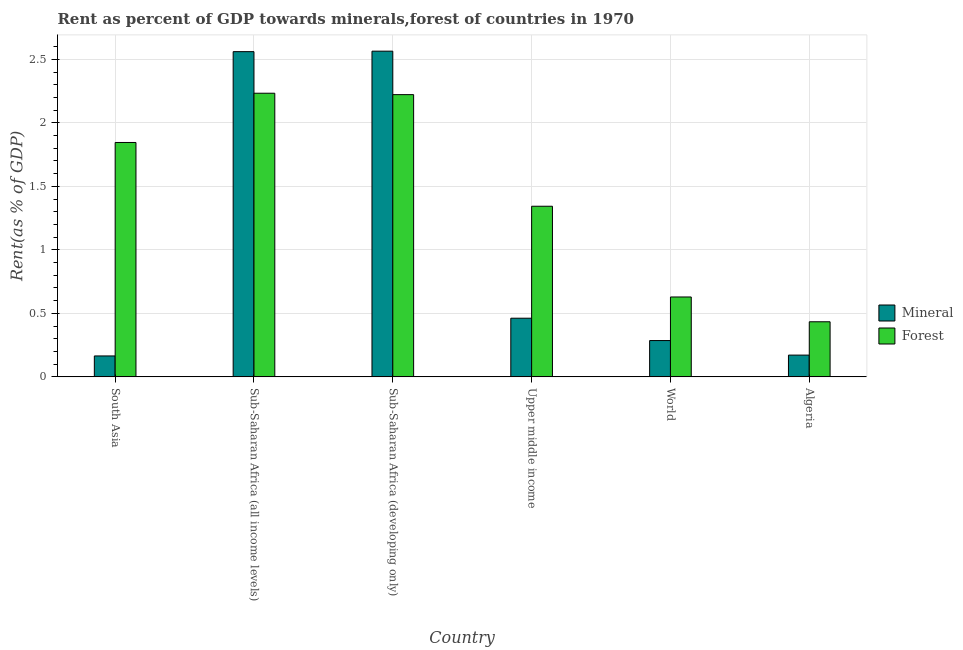Are the number of bars on each tick of the X-axis equal?
Offer a terse response. Yes. How many bars are there on the 4th tick from the left?
Provide a succinct answer. 2. What is the label of the 6th group of bars from the left?
Provide a short and direct response. Algeria. In how many cases, is the number of bars for a given country not equal to the number of legend labels?
Your answer should be very brief. 0. What is the forest rent in Upper middle income?
Keep it short and to the point. 1.34. Across all countries, what is the maximum mineral rent?
Provide a succinct answer. 2.56. Across all countries, what is the minimum mineral rent?
Keep it short and to the point. 0.16. In which country was the forest rent maximum?
Provide a short and direct response. Sub-Saharan Africa (all income levels). In which country was the forest rent minimum?
Your answer should be compact. Algeria. What is the total forest rent in the graph?
Keep it short and to the point. 8.71. What is the difference between the mineral rent in Sub-Saharan Africa (all income levels) and that in Upper middle income?
Make the answer very short. 2.1. What is the difference between the mineral rent in Sub-Saharan Africa (developing only) and the forest rent in South Asia?
Your answer should be very brief. 0.72. What is the average forest rent per country?
Offer a very short reply. 1.45. What is the difference between the mineral rent and forest rent in Sub-Saharan Africa (all income levels)?
Your answer should be compact. 0.33. What is the ratio of the mineral rent in Upper middle income to that in World?
Your response must be concise. 1.62. Is the difference between the forest rent in Algeria and World greater than the difference between the mineral rent in Algeria and World?
Keep it short and to the point. No. What is the difference between the highest and the second highest forest rent?
Make the answer very short. 0.01. What is the difference between the highest and the lowest mineral rent?
Your answer should be compact. 2.4. What does the 2nd bar from the left in Algeria represents?
Offer a terse response. Forest. What does the 2nd bar from the right in Upper middle income represents?
Offer a very short reply. Mineral. How many bars are there?
Make the answer very short. 12. How many countries are there in the graph?
Your answer should be compact. 6. Are the values on the major ticks of Y-axis written in scientific E-notation?
Ensure brevity in your answer.  No. Does the graph contain any zero values?
Offer a very short reply. No. Does the graph contain grids?
Your answer should be compact. Yes. Where does the legend appear in the graph?
Ensure brevity in your answer.  Center right. What is the title of the graph?
Ensure brevity in your answer.  Rent as percent of GDP towards minerals,forest of countries in 1970. What is the label or title of the X-axis?
Your response must be concise. Country. What is the label or title of the Y-axis?
Your answer should be very brief. Rent(as % of GDP). What is the Rent(as % of GDP) of Mineral in South Asia?
Keep it short and to the point. 0.16. What is the Rent(as % of GDP) of Forest in South Asia?
Give a very brief answer. 1.85. What is the Rent(as % of GDP) of Mineral in Sub-Saharan Africa (all income levels)?
Give a very brief answer. 2.56. What is the Rent(as % of GDP) in Forest in Sub-Saharan Africa (all income levels)?
Your answer should be compact. 2.23. What is the Rent(as % of GDP) of Mineral in Sub-Saharan Africa (developing only)?
Your answer should be very brief. 2.56. What is the Rent(as % of GDP) in Forest in Sub-Saharan Africa (developing only)?
Provide a succinct answer. 2.22. What is the Rent(as % of GDP) in Mineral in Upper middle income?
Your response must be concise. 0.46. What is the Rent(as % of GDP) in Forest in Upper middle income?
Offer a very short reply. 1.34. What is the Rent(as % of GDP) of Mineral in World?
Your answer should be very brief. 0.29. What is the Rent(as % of GDP) of Forest in World?
Your response must be concise. 0.63. What is the Rent(as % of GDP) in Mineral in Algeria?
Offer a very short reply. 0.17. What is the Rent(as % of GDP) of Forest in Algeria?
Provide a succinct answer. 0.43. Across all countries, what is the maximum Rent(as % of GDP) of Mineral?
Offer a very short reply. 2.56. Across all countries, what is the maximum Rent(as % of GDP) of Forest?
Give a very brief answer. 2.23. Across all countries, what is the minimum Rent(as % of GDP) of Mineral?
Your response must be concise. 0.16. Across all countries, what is the minimum Rent(as % of GDP) of Forest?
Offer a terse response. 0.43. What is the total Rent(as % of GDP) in Mineral in the graph?
Give a very brief answer. 6.21. What is the total Rent(as % of GDP) of Forest in the graph?
Make the answer very short. 8.71. What is the difference between the Rent(as % of GDP) of Mineral in South Asia and that in Sub-Saharan Africa (all income levels)?
Keep it short and to the point. -2.4. What is the difference between the Rent(as % of GDP) of Forest in South Asia and that in Sub-Saharan Africa (all income levels)?
Provide a succinct answer. -0.39. What is the difference between the Rent(as % of GDP) of Mineral in South Asia and that in Sub-Saharan Africa (developing only)?
Give a very brief answer. -2.4. What is the difference between the Rent(as % of GDP) in Forest in South Asia and that in Sub-Saharan Africa (developing only)?
Provide a succinct answer. -0.38. What is the difference between the Rent(as % of GDP) in Mineral in South Asia and that in Upper middle income?
Provide a short and direct response. -0.3. What is the difference between the Rent(as % of GDP) in Forest in South Asia and that in Upper middle income?
Offer a terse response. 0.5. What is the difference between the Rent(as % of GDP) in Mineral in South Asia and that in World?
Provide a short and direct response. -0.12. What is the difference between the Rent(as % of GDP) in Forest in South Asia and that in World?
Give a very brief answer. 1.22. What is the difference between the Rent(as % of GDP) of Mineral in South Asia and that in Algeria?
Ensure brevity in your answer.  -0.01. What is the difference between the Rent(as % of GDP) of Forest in South Asia and that in Algeria?
Provide a succinct answer. 1.41. What is the difference between the Rent(as % of GDP) in Mineral in Sub-Saharan Africa (all income levels) and that in Sub-Saharan Africa (developing only)?
Provide a short and direct response. -0. What is the difference between the Rent(as % of GDP) in Forest in Sub-Saharan Africa (all income levels) and that in Sub-Saharan Africa (developing only)?
Make the answer very short. 0.01. What is the difference between the Rent(as % of GDP) in Mineral in Sub-Saharan Africa (all income levels) and that in Upper middle income?
Give a very brief answer. 2.1. What is the difference between the Rent(as % of GDP) in Forest in Sub-Saharan Africa (all income levels) and that in Upper middle income?
Your response must be concise. 0.89. What is the difference between the Rent(as % of GDP) of Mineral in Sub-Saharan Africa (all income levels) and that in World?
Provide a succinct answer. 2.27. What is the difference between the Rent(as % of GDP) of Forest in Sub-Saharan Africa (all income levels) and that in World?
Offer a terse response. 1.6. What is the difference between the Rent(as % of GDP) of Mineral in Sub-Saharan Africa (all income levels) and that in Algeria?
Provide a short and direct response. 2.39. What is the difference between the Rent(as % of GDP) in Forest in Sub-Saharan Africa (all income levels) and that in Algeria?
Provide a short and direct response. 1.8. What is the difference between the Rent(as % of GDP) of Mineral in Sub-Saharan Africa (developing only) and that in Upper middle income?
Your answer should be very brief. 2.1. What is the difference between the Rent(as % of GDP) in Forest in Sub-Saharan Africa (developing only) and that in Upper middle income?
Keep it short and to the point. 0.88. What is the difference between the Rent(as % of GDP) of Mineral in Sub-Saharan Africa (developing only) and that in World?
Keep it short and to the point. 2.28. What is the difference between the Rent(as % of GDP) in Forest in Sub-Saharan Africa (developing only) and that in World?
Provide a short and direct response. 1.59. What is the difference between the Rent(as % of GDP) of Mineral in Sub-Saharan Africa (developing only) and that in Algeria?
Offer a terse response. 2.39. What is the difference between the Rent(as % of GDP) of Forest in Sub-Saharan Africa (developing only) and that in Algeria?
Your response must be concise. 1.79. What is the difference between the Rent(as % of GDP) in Mineral in Upper middle income and that in World?
Offer a very short reply. 0.18. What is the difference between the Rent(as % of GDP) in Forest in Upper middle income and that in World?
Provide a short and direct response. 0.71. What is the difference between the Rent(as % of GDP) in Mineral in Upper middle income and that in Algeria?
Give a very brief answer. 0.29. What is the difference between the Rent(as % of GDP) of Forest in Upper middle income and that in Algeria?
Provide a short and direct response. 0.91. What is the difference between the Rent(as % of GDP) in Mineral in World and that in Algeria?
Your response must be concise. 0.11. What is the difference between the Rent(as % of GDP) in Forest in World and that in Algeria?
Give a very brief answer. 0.2. What is the difference between the Rent(as % of GDP) of Mineral in South Asia and the Rent(as % of GDP) of Forest in Sub-Saharan Africa (all income levels)?
Your answer should be very brief. -2.07. What is the difference between the Rent(as % of GDP) in Mineral in South Asia and the Rent(as % of GDP) in Forest in Sub-Saharan Africa (developing only)?
Offer a terse response. -2.06. What is the difference between the Rent(as % of GDP) of Mineral in South Asia and the Rent(as % of GDP) of Forest in Upper middle income?
Provide a short and direct response. -1.18. What is the difference between the Rent(as % of GDP) of Mineral in South Asia and the Rent(as % of GDP) of Forest in World?
Give a very brief answer. -0.46. What is the difference between the Rent(as % of GDP) of Mineral in South Asia and the Rent(as % of GDP) of Forest in Algeria?
Provide a succinct answer. -0.27. What is the difference between the Rent(as % of GDP) of Mineral in Sub-Saharan Africa (all income levels) and the Rent(as % of GDP) of Forest in Sub-Saharan Africa (developing only)?
Your response must be concise. 0.34. What is the difference between the Rent(as % of GDP) in Mineral in Sub-Saharan Africa (all income levels) and the Rent(as % of GDP) in Forest in Upper middle income?
Offer a very short reply. 1.22. What is the difference between the Rent(as % of GDP) in Mineral in Sub-Saharan Africa (all income levels) and the Rent(as % of GDP) in Forest in World?
Provide a succinct answer. 1.93. What is the difference between the Rent(as % of GDP) of Mineral in Sub-Saharan Africa (all income levels) and the Rent(as % of GDP) of Forest in Algeria?
Provide a succinct answer. 2.13. What is the difference between the Rent(as % of GDP) in Mineral in Sub-Saharan Africa (developing only) and the Rent(as % of GDP) in Forest in Upper middle income?
Give a very brief answer. 1.22. What is the difference between the Rent(as % of GDP) in Mineral in Sub-Saharan Africa (developing only) and the Rent(as % of GDP) in Forest in World?
Offer a very short reply. 1.94. What is the difference between the Rent(as % of GDP) of Mineral in Sub-Saharan Africa (developing only) and the Rent(as % of GDP) of Forest in Algeria?
Your answer should be very brief. 2.13. What is the difference between the Rent(as % of GDP) in Mineral in Upper middle income and the Rent(as % of GDP) in Forest in World?
Offer a very short reply. -0.17. What is the difference between the Rent(as % of GDP) in Mineral in Upper middle income and the Rent(as % of GDP) in Forest in Algeria?
Offer a very short reply. 0.03. What is the difference between the Rent(as % of GDP) of Mineral in World and the Rent(as % of GDP) of Forest in Algeria?
Ensure brevity in your answer.  -0.15. What is the average Rent(as % of GDP) of Mineral per country?
Offer a terse response. 1.03. What is the average Rent(as % of GDP) in Forest per country?
Keep it short and to the point. 1.45. What is the difference between the Rent(as % of GDP) of Mineral and Rent(as % of GDP) of Forest in South Asia?
Give a very brief answer. -1.68. What is the difference between the Rent(as % of GDP) of Mineral and Rent(as % of GDP) of Forest in Sub-Saharan Africa (all income levels)?
Your answer should be compact. 0.33. What is the difference between the Rent(as % of GDP) of Mineral and Rent(as % of GDP) of Forest in Sub-Saharan Africa (developing only)?
Provide a short and direct response. 0.34. What is the difference between the Rent(as % of GDP) of Mineral and Rent(as % of GDP) of Forest in Upper middle income?
Provide a succinct answer. -0.88. What is the difference between the Rent(as % of GDP) in Mineral and Rent(as % of GDP) in Forest in World?
Make the answer very short. -0.34. What is the difference between the Rent(as % of GDP) in Mineral and Rent(as % of GDP) in Forest in Algeria?
Your answer should be compact. -0.26. What is the ratio of the Rent(as % of GDP) in Mineral in South Asia to that in Sub-Saharan Africa (all income levels)?
Provide a short and direct response. 0.06. What is the ratio of the Rent(as % of GDP) of Forest in South Asia to that in Sub-Saharan Africa (all income levels)?
Give a very brief answer. 0.83. What is the ratio of the Rent(as % of GDP) in Mineral in South Asia to that in Sub-Saharan Africa (developing only)?
Your answer should be compact. 0.06. What is the ratio of the Rent(as % of GDP) of Forest in South Asia to that in Sub-Saharan Africa (developing only)?
Provide a short and direct response. 0.83. What is the ratio of the Rent(as % of GDP) in Mineral in South Asia to that in Upper middle income?
Make the answer very short. 0.36. What is the ratio of the Rent(as % of GDP) in Forest in South Asia to that in Upper middle income?
Make the answer very short. 1.37. What is the ratio of the Rent(as % of GDP) in Mineral in South Asia to that in World?
Provide a succinct answer. 0.58. What is the ratio of the Rent(as % of GDP) in Forest in South Asia to that in World?
Ensure brevity in your answer.  2.93. What is the ratio of the Rent(as % of GDP) in Mineral in South Asia to that in Algeria?
Your answer should be compact. 0.96. What is the ratio of the Rent(as % of GDP) of Forest in South Asia to that in Algeria?
Provide a succinct answer. 4.25. What is the ratio of the Rent(as % of GDP) in Forest in Sub-Saharan Africa (all income levels) to that in Sub-Saharan Africa (developing only)?
Make the answer very short. 1. What is the ratio of the Rent(as % of GDP) in Mineral in Sub-Saharan Africa (all income levels) to that in Upper middle income?
Ensure brevity in your answer.  5.54. What is the ratio of the Rent(as % of GDP) in Forest in Sub-Saharan Africa (all income levels) to that in Upper middle income?
Make the answer very short. 1.66. What is the ratio of the Rent(as % of GDP) of Mineral in Sub-Saharan Africa (all income levels) to that in World?
Provide a short and direct response. 8.95. What is the ratio of the Rent(as % of GDP) in Forest in Sub-Saharan Africa (all income levels) to that in World?
Your answer should be very brief. 3.55. What is the ratio of the Rent(as % of GDP) of Mineral in Sub-Saharan Africa (all income levels) to that in Algeria?
Give a very brief answer. 14.94. What is the ratio of the Rent(as % of GDP) of Forest in Sub-Saharan Africa (all income levels) to that in Algeria?
Provide a succinct answer. 5.15. What is the ratio of the Rent(as % of GDP) of Mineral in Sub-Saharan Africa (developing only) to that in Upper middle income?
Make the answer very short. 5.55. What is the ratio of the Rent(as % of GDP) of Forest in Sub-Saharan Africa (developing only) to that in Upper middle income?
Offer a terse response. 1.65. What is the ratio of the Rent(as % of GDP) of Mineral in Sub-Saharan Africa (developing only) to that in World?
Offer a very short reply. 8.97. What is the ratio of the Rent(as % of GDP) in Forest in Sub-Saharan Africa (developing only) to that in World?
Give a very brief answer. 3.53. What is the ratio of the Rent(as % of GDP) in Mineral in Sub-Saharan Africa (developing only) to that in Algeria?
Give a very brief answer. 14.96. What is the ratio of the Rent(as % of GDP) of Forest in Sub-Saharan Africa (developing only) to that in Algeria?
Offer a very short reply. 5.12. What is the ratio of the Rent(as % of GDP) of Mineral in Upper middle income to that in World?
Your answer should be very brief. 1.62. What is the ratio of the Rent(as % of GDP) in Forest in Upper middle income to that in World?
Provide a succinct answer. 2.14. What is the ratio of the Rent(as % of GDP) of Mineral in Upper middle income to that in Algeria?
Your response must be concise. 2.69. What is the ratio of the Rent(as % of GDP) of Forest in Upper middle income to that in Algeria?
Offer a terse response. 3.1. What is the ratio of the Rent(as % of GDP) in Mineral in World to that in Algeria?
Offer a terse response. 1.67. What is the ratio of the Rent(as % of GDP) in Forest in World to that in Algeria?
Keep it short and to the point. 1.45. What is the difference between the highest and the second highest Rent(as % of GDP) in Mineral?
Keep it short and to the point. 0. What is the difference between the highest and the second highest Rent(as % of GDP) in Forest?
Provide a short and direct response. 0.01. What is the difference between the highest and the lowest Rent(as % of GDP) of Mineral?
Your answer should be very brief. 2.4. What is the difference between the highest and the lowest Rent(as % of GDP) of Forest?
Provide a succinct answer. 1.8. 